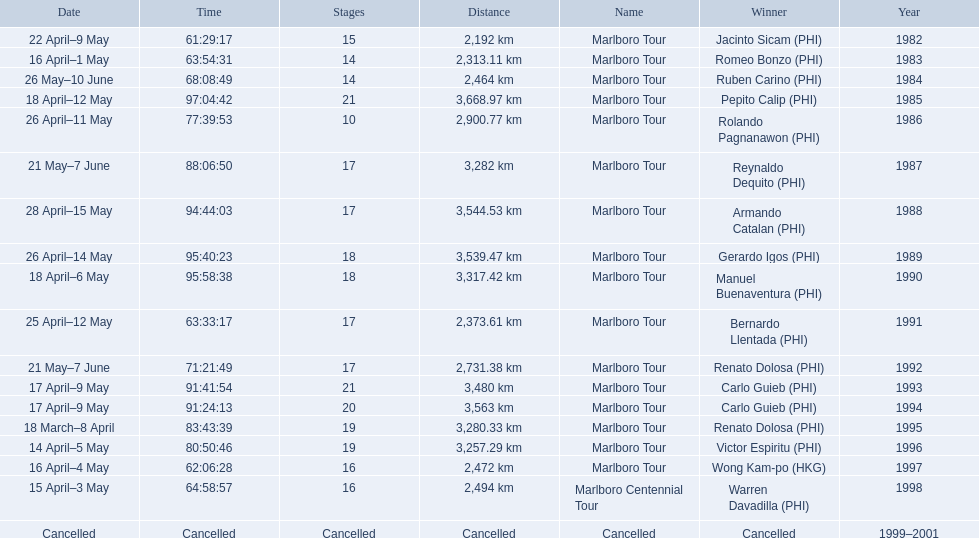How far did the marlboro tour travel each year? 2,192 km, 2,313.11 km, 2,464 km, 3,668.97 km, 2,900.77 km, 3,282 km, 3,544.53 km, 3,539.47 km, 3,317.42 km, 2,373.61 km, 2,731.38 km, 3,480 km, 3,563 km, 3,280.33 km, 3,257.29 km, 2,472 km, 2,494 km, Cancelled. Parse the full table in json format. {'header': ['Date', 'Time', 'Stages', 'Distance', 'Name', 'Winner', 'Year'], 'rows': [['22 April–9 May', '61:29:17', '15', '2,192\xa0km', 'Marlboro Tour', 'Jacinto Sicam\xa0(PHI)', '1982'], ['16 April–1 May', '63:54:31', '14', '2,313.11\xa0km', 'Marlboro Tour', 'Romeo Bonzo\xa0(PHI)', '1983'], ['26 May–10 June', '68:08:49', '14', '2,464\xa0km', 'Marlboro Tour', 'Ruben Carino\xa0(PHI)', '1984'], ['18 April–12 May', '97:04:42', '21', '3,668.97\xa0km', 'Marlboro Tour', 'Pepito Calip\xa0(PHI)', '1985'], ['26 April–11 May', '77:39:53', '10', '2,900.77\xa0km', 'Marlboro Tour', 'Rolando Pagnanawon\xa0(PHI)', '1986'], ['21 May–7 June', '88:06:50', '17', '3,282\xa0km', 'Marlboro Tour', 'Reynaldo Dequito\xa0(PHI)', '1987'], ['28 April–15 May', '94:44:03', '17', '3,544.53\xa0km', 'Marlboro Tour', 'Armando Catalan\xa0(PHI)', '1988'], ['26 April–14 May', '95:40:23', '18', '3,539.47\xa0km', 'Marlboro Tour', 'Gerardo Igos\xa0(PHI)', '1989'], ['18 April–6 May', '95:58:38', '18', '3,317.42\xa0km', 'Marlboro Tour', 'Manuel Buenaventura\xa0(PHI)', '1990'], ['25 April–12 May', '63:33:17', '17', '2,373.61\xa0km', 'Marlboro Tour', 'Bernardo Llentada\xa0(PHI)', '1991'], ['21 May–7 June', '71:21:49', '17', '2,731.38\xa0km', 'Marlboro Tour', 'Renato Dolosa\xa0(PHI)', '1992'], ['17 April–9 May', '91:41:54', '21', '3,480\xa0km', 'Marlboro Tour', 'Carlo Guieb\xa0(PHI)', '1993'], ['17 April–9 May', '91:24:13', '20', '3,563\xa0km', 'Marlboro Tour', 'Carlo Guieb\xa0(PHI)', '1994'], ['18 March–8 April', '83:43:39', '19', '3,280.33\xa0km', 'Marlboro Tour', 'Renato Dolosa\xa0(PHI)', '1995'], ['14 April–5 May', '80:50:46', '19', '3,257.29\xa0km', 'Marlboro Tour', 'Victor Espiritu\xa0(PHI)', '1996'], ['16 April–4 May', '62:06:28', '16', '2,472\xa0km', 'Marlboro Tour', 'Wong Kam-po\xa0(HKG)', '1997'], ['15 April–3 May', '64:58:57', '16', '2,494\xa0km', 'Marlboro Centennial Tour', 'Warren Davadilla\xa0(PHI)', '1998'], ['Cancelled', 'Cancelled', 'Cancelled', 'Cancelled', 'Cancelled', 'Cancelled', '1999–2001']]} In what year did they travel the furthest? 1985. How far did they travel that year? 3,668.97 km. 